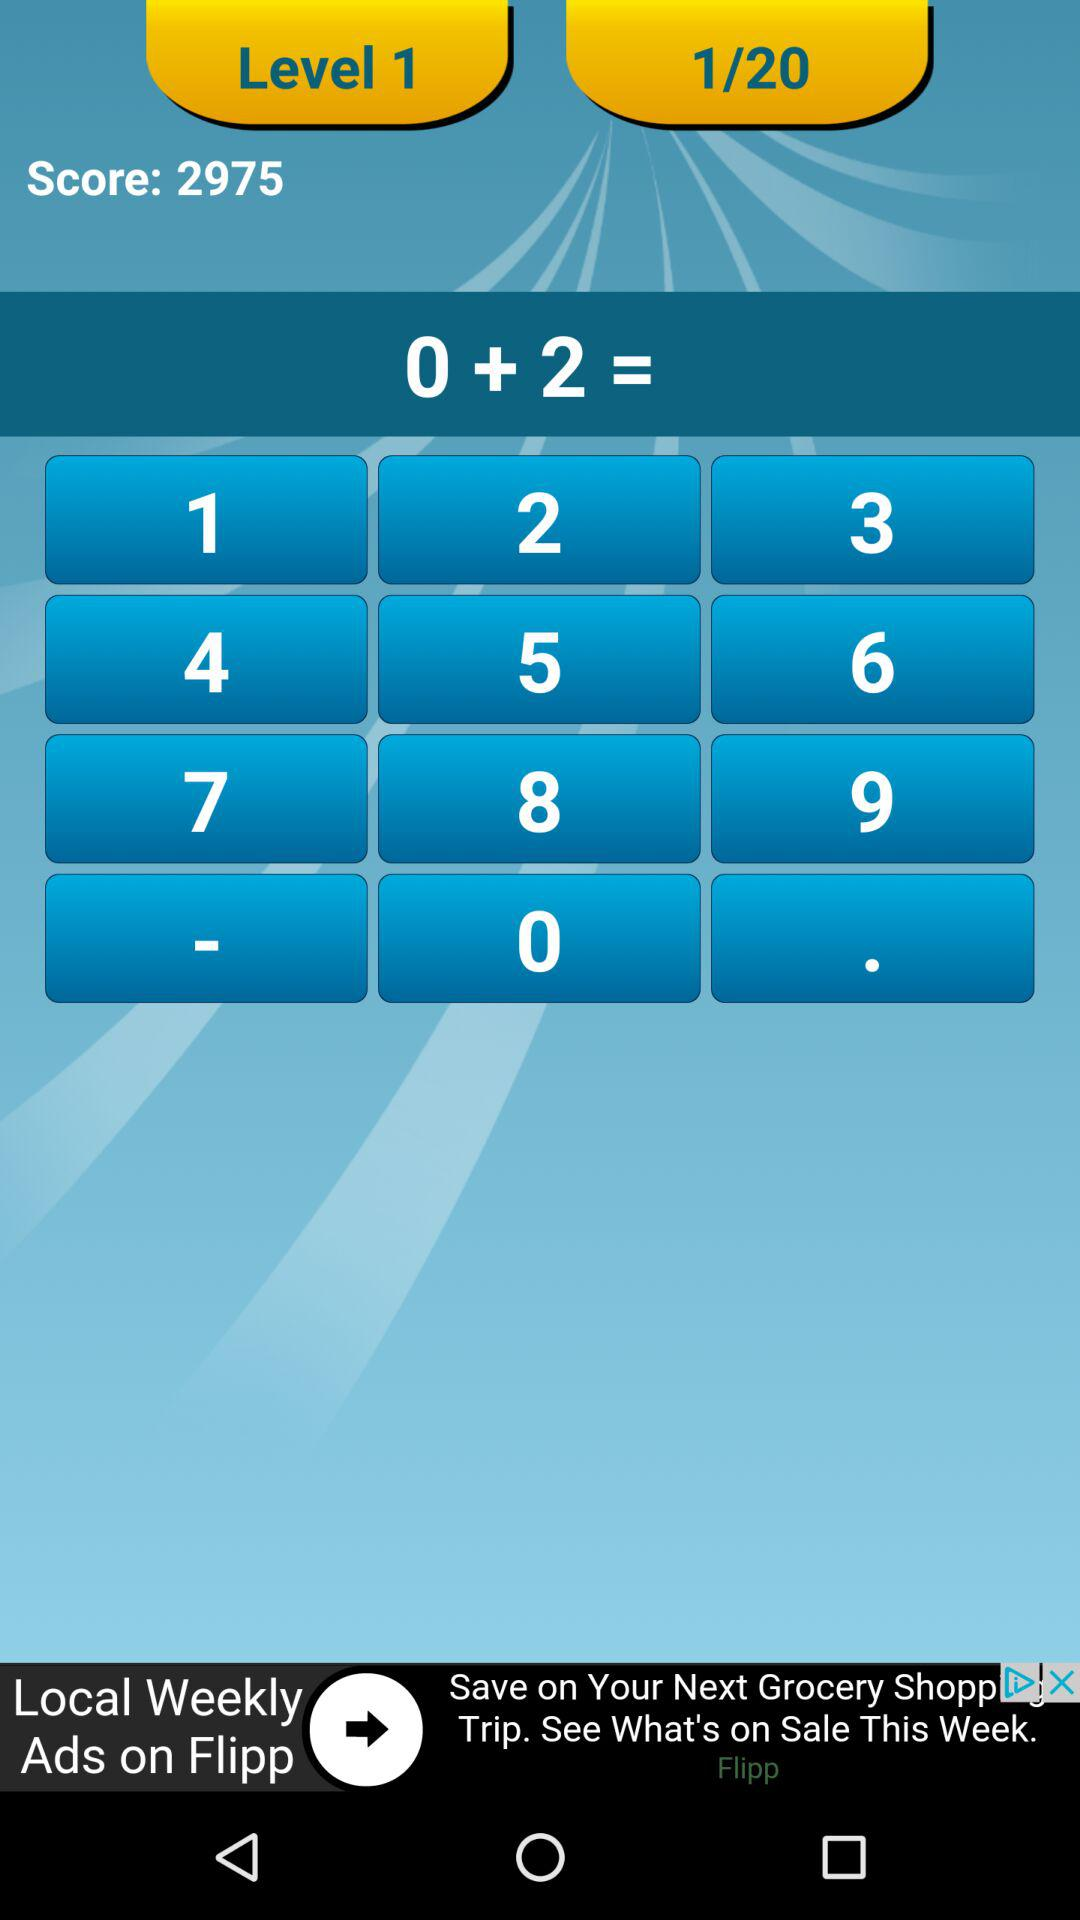What is the total number of levels? The total number of levels is 20. 